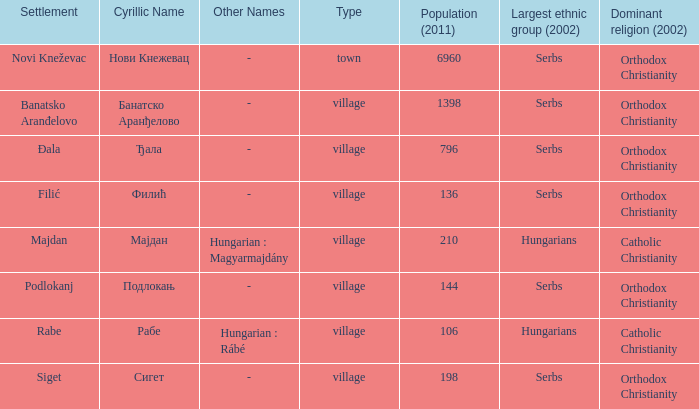What is the largest ethnic group of the settlement with the cyrillic name of банатско аранђелово? Serbs. Would you mind parsing the complete table? {'header': ['Settlement', 'Cyrillic Name', 'Other Names', 'Type', 'Population (2011)', 'Largest ethnic group (2002)', 'Dominant religion (2002)'], 'rows': [['Novi Kneževac', 'Нови Кнежевац', '-', 'town', '6960', 'Serbs', 'Orthodox Christianity'], ['Banatsko Aranđelovo', 'Банатско Аранђелово', '-', 'village', '1398', 'Serbs', 'Orthodox Christianity'], ['Đala', 'Ђала', '-', 'village', '796', 'Serbs', 'Orthodox Christianity'], ['Filić', 'Филић', '-', 'village', '136', 'Serbs', 'Orthodox Christianity'], ['Majdan', 'Мајдан', 'Hungarian : Magyarmajdány', 'village', '210', 'Hungarians', 'Catholic Christianity'], ['Podlokanj', 'Подлокањ', '-', 'village', '144', 'Serbs', 'Orthodox Christianity'], ['Rabe', 'Рабе', 'Hungarian : Rábé', 'village', '106', 'Hungarians', 'Catholic Christianity'], ['Siget', 'Сигет', '-', 'village', '198', 'Serbs', 'Orthodox Christianity']]} 